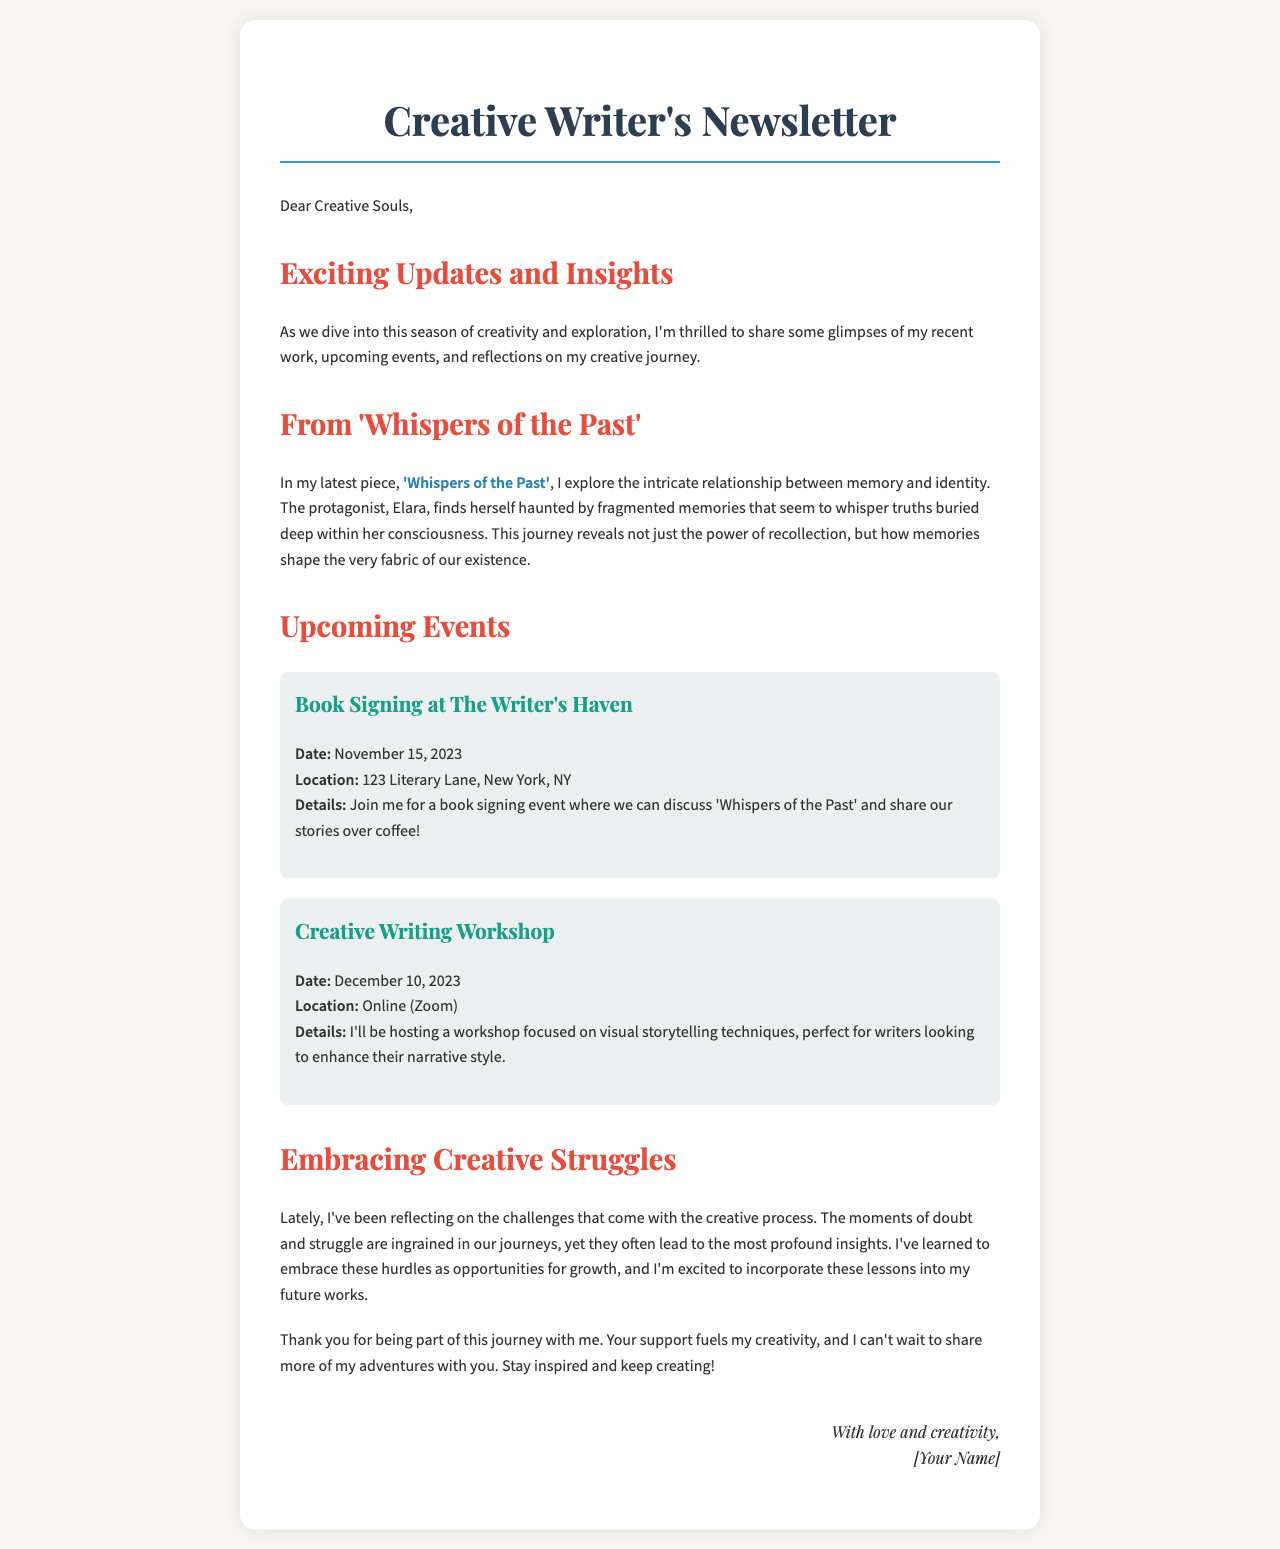What is the title of the latest piece? The title of the latest piece is provided in the document, which is 'Whispers of the Past'.
Answer: 'Whispers of the Past' When is the book signing event taking place? The date for the book signing event is specified in the upcoming events section.
Answer: November 15, 2023 What is the location of the creative writing workshop? The location for the creative writing workshop is mentioned in the document as taking place online.
Answer: Online (Zoom) Who is the protagonist in 'Whispers of the Past'? The protagonist's name is stated in the excerpt from the latest piece.
Answer: Elara What is the main theme explored in 'Whispers of the Past'? The document highlights that the piece deals with the relationship between memory and identity.
Answer: Memory and identity What insights does the writer share about creative struggles? The writer reflects on the challenges of creativity and the lessons learned from them in the letter.
Answer: Opportunities for growth 